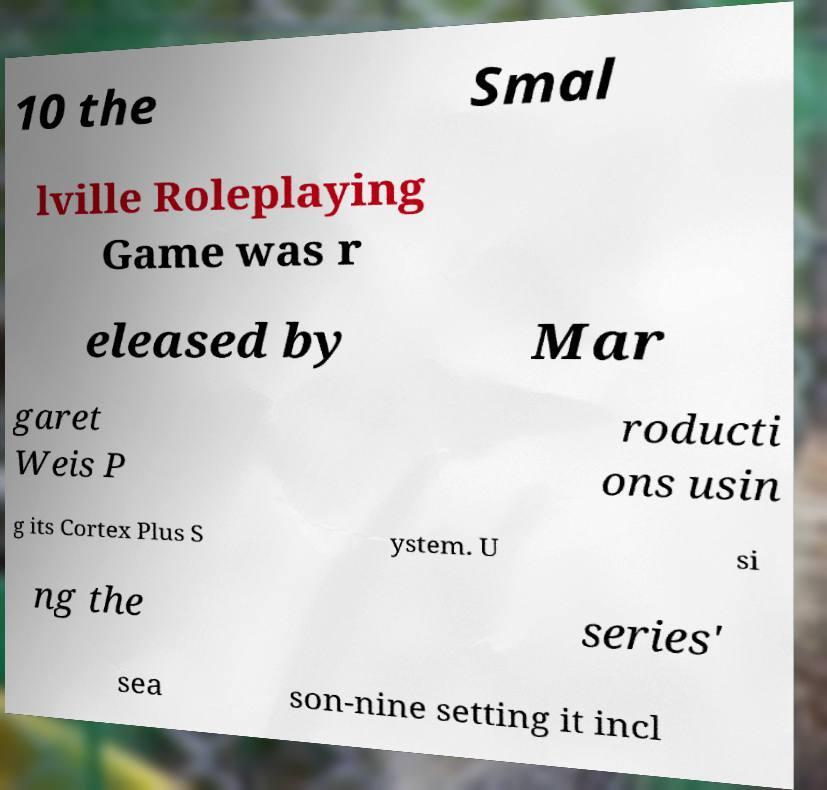Could you assist in decoding the text presented in this image and type it out clearly? 10 the Smal lville Roleplaying Game was r eleased by Mar garet Weis P roducti ons usin g its Cortex Plus S ystem. U si ng the series' sea son-nine setting it incl 